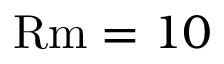Convert formula to latex. <formula><loc_0><loc_0><loc_500><loc_500>R m = 1 0</formula> 